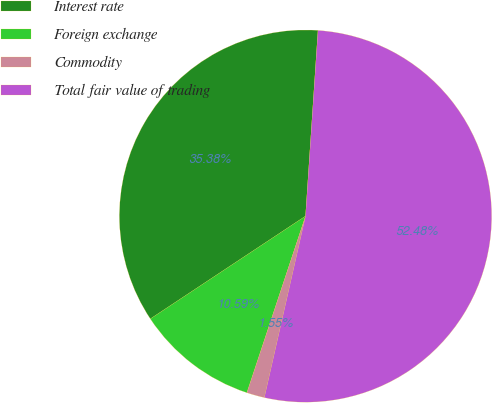Convert chart. <chart><loc_0><loc_0><loc_500><loc_500><pie_chart><fcel>Interest rate<fcel>Foreign exchange<fcel>Commodity<fcel>Total fair value of trading<nl><fcel>35.38%<fcel>10.59%<fcel>1.55%<fcel>52.49%<nl></chart> 